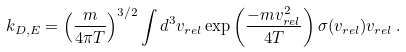Convert formula to latex. <formula><loc_0><loc_0><loc_500><loc_500>k _ { D , E } = \left ( \frac { m } { 4 \pi T } \right ) ^ { 3 / 2 } \int d ^ { 3 } v _ { r e l } \exp \left ( \frac { - m v _ { r e l } ^ { 2 } } { 4 T } \right ) \sigma ( v _ { r e l } ) v _ { r e l } \, .</formula> 